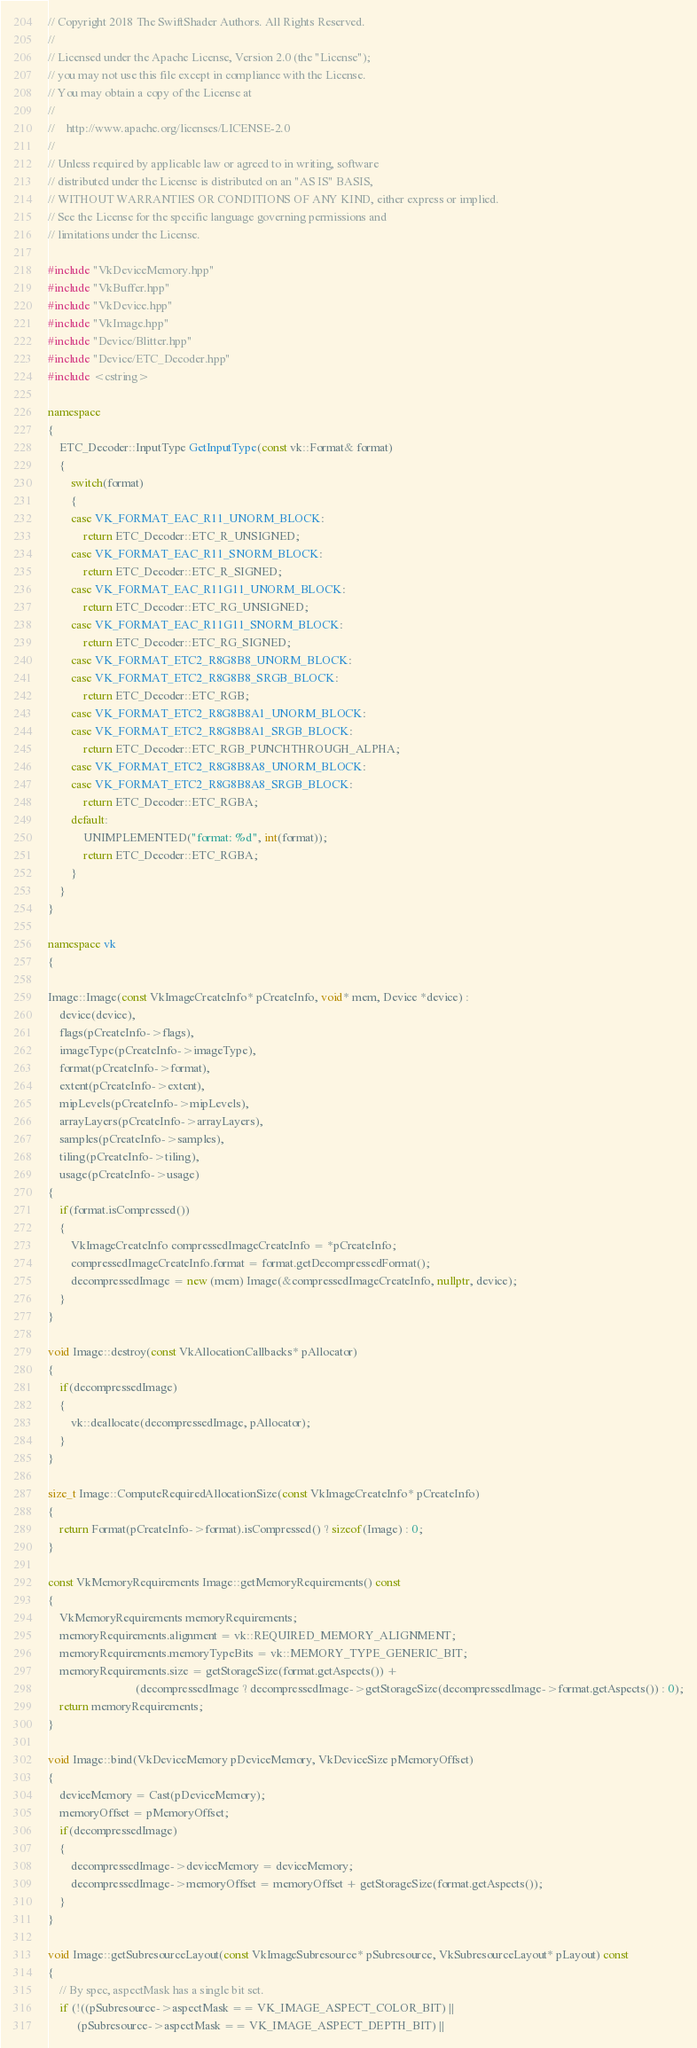Convert code to text. <code><loc_0><loc_0><loc_500><loc_500><_C++_>// Copyright 2018 The SwiftShader Authors. All Rights Reserved.
//
// Licensed under the Apache License, Version 2.0 (the "License");
// you may not use this file except in compliance with the License.
// You may obtain a copy of the License at
//
//    http://www.apache.org/licenses/LICENSE-2.0
//
// Unless required by applicable law or agreed to in writing, software
// distributed under the License is distributed on an "AS IS" BASIS,
// WITHOUT WARRANTIES OR CONDITIONS OF ANY KIND, either express or implied.
// See the License for the specific language governing permissions and
// limitations under the License.

#include "VkDeviceMemory.hpp"
#include "VkBuffer.hpp"
#include "VkDevice.hpp"
#include "VkImage.hpp"
#include "Device/Blitter.hpp"
#include "Device/ETC_Decoder.hpp"
#include <cstring>

namespace
{
	ETC_Decoder::InputType GetInputType(const vk::Format& format)
	{
		switch(format)
		{
		case VK_FORMAT_EAC_R11_UNORM_BLOCK:
			return ETC_Decoder::ETC_R_UNSIGNED;
		case VK_FORMAT_EAC_R11_SNORM_BLOCK:
			return ETC_Decoder::ETC_R_SIGNED;
		case VK_FORMAT_EAC_R11G11_UNORM_BLOCK:
			return ETC_Decoder::ETC_RG_UNSIGNED;
		case VK_FORMAT_EAC_R11G11_SNORM_BLOCK:
			return ETC_Decoder::ETC_RG_SIGNED;
		case VK_FORMAT_ETC2_R8G8B8_UNORM_BLOCK:
		case VK_FORMAT_ETC2_R8G8B8_SRGB_BLOCK:
			return ETC_Decoder::ETC_RGB;
		case VK_FORMAT_ETC2_R8G8B8A1_UNORM_BLOCK:
		case VK_FORMAT_ETC2_R8G8B8A1_SRGB_BLOCK:
			return ETC_Decoder::ETC_RGB_PUNCHTHROUGH_ALPHA;
		case VK_FORMAT_ETC2_R8G8B8A8_UNORM_BLOCK:
		case VK_FORMAT_ETC2_R8G8B8A8_SRGB_BLOCK:
			return ETC_Decoder::ETC_RGBA;
		default:
			UNIMPLEMENTED("format: %d", int(format));
			return ETC_Decoder::ETC_RGBA;
		}
	}
}

namespace vk
{

Image::Image(const VkImageCreateInfo* pCreateInfo, void* mem, Device *device) :
	device(device),
	flags(pCreateInfo->flags),
	imageType(pCreateInfo->imageType),
	format(pCreateInfo->format),
	extent(pCreateInfo->extent),
	mipLevels(pCreateInfo->mipLevels),
	arrayLayers(pCreateInfo->arrayLayers),
	samples(pCreateInfo->samples),
	tiling(pCreateInfo->tiling),
	usage(pCreateInfo->usage)
{
	if(format.isCompressed())
	{
		VkImageCreateInfo compressedImageCreateInfo = *pCreateInfo;
		compressedImageCreateInfo.format = format.getDecompressedFormat();
		decompressedImage = new (mem) Image(&compressedImageCreateInfo, nullptr, device);
	}
}

void Image::destroy(const VkAllocationCallbacks* pAllocator)
{
	if(decompressedImage)
	{
		vk::deallocate(decompressedImage, pAllocator);
	}
}

size_t Image::ComputeRequiredAllocationSize(const VkImageCreateInfo* pCreateInfo)
{
	return Format(pCreateInfo->format).isCompressed() ? sizeof(Image) : 0;
}

const VkMemoryRequirements Image::getMemoryRequirements() const
{
	VkMemoryRequirements memoryRequirements;
	memoryRequirements.alignment = vk::REQUIRED_MEMORY_ALIGNMENT;
	memoryRequirements.memoryTypeBits = vk::MEMORY_TYPE_GENERIC_BIT;
	memoryRequirements.size = getStorageSize(format.getAspects()) +
	                          (decompressedImage ? decompressedImage->getStorageSize(decompressedImage->format.getAspects()) : 0);
	return memoryRequirements;
}

void Image::bind(VkDeviceMemory pDeviceMemory, VkDeviceSize pMemoryOffset)
{
	deviceMemory = Cast(pDeviceMemory);
	memoryOffset = pMemoryOffset;
	if(decompressedImage)
	{
		decompressedImage->deviceMemory = deviceMemory;
		decompressedImage->memoryOffset = memoryOffset + getStorageSize(format.getAspects());
	}
}

void Image::getSubresourceLayout(const VkImageSubresource* pSubresource, VkSubresourceLayout* pLayout) const
{
	// By spec, aspectMask has a single bit set.
	if (!((pSubresource->aspectMask == VK_IMAGE_ASPECT_COLOR_BIT) ||
	      (pSubresource->aspectMask == VK_IMAGE_ASPECT_DEPTH_BIT) ||</code> 